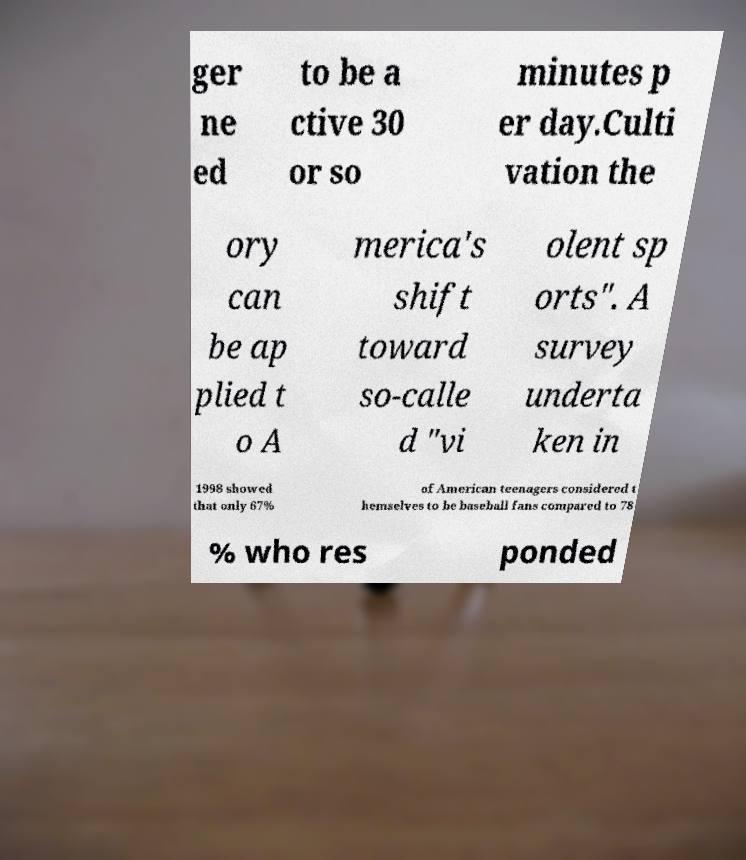I need the written content from this picture converted into text. Can you do that? ger ne ed to be a ctive 30 or so minutes p er day.Culti vation the ory can be ap plied t o A merica's shift toward so-calle d "vi olent sp orts". A survey underta ken in 1998 showed that only 67% of American teenagers considered t hemselves to be baseball fans compared to 78 % who res ponded 